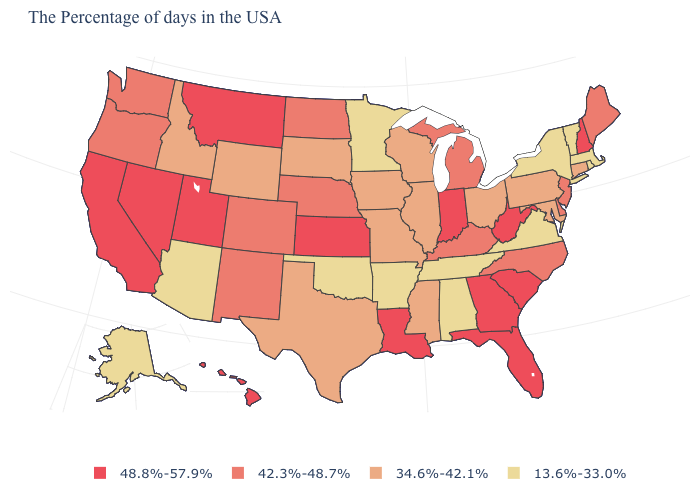Does the first symbol in the legend represent the smallest category?
Write a very short answer. No. Among the states that border New York , does New Jersey have the highest value?
Write a very short answer. Yes. What is the value of Vermont?
Be succinct. 13.6%-33.0%. What is the value of Kentucky?
Short answer required. 42.3%-48.7%. How many symbols are there in the legend?
Keep it brief. 4. What is the value of California?
Quick response, please. 48.8%-57.9%. Does West Virginia have the same value as Wisconsin?
Give a very brief answer. No. What is the value of Massachusetts?
Short answer required. 13.6%-33.0%. What is the value of Pennsylvania?
Write a very short answer. 34.6%-42.1%. What is the value of Arizona?
Be succinct. 13.6%-33.0%. Does Oklahoma have the same value as Maryland?
Short answer required. No. Which states have the highest value in the USA?
Give a very brief answer. New Hampshire, South Carolina, West Virginia, Florida, Georgia, Indiana, Louisiana, Kansas, Utah, Montana, Nevada, California, Hawaii. What is the value of Iowa?
Answer briefly. 34.6%-42.1%. Which states have the lowest value in the USA?
Short answer required. Massachusetts, Rhode Island, Vermont, New York, Virginia, Alabama, Tennessee, Arkansas, Minnesota, Oklahoma, Arizona, Alaska. What is the lowest value in states that border Illinois?
Concise answer only. 34.6%-42.1%. 